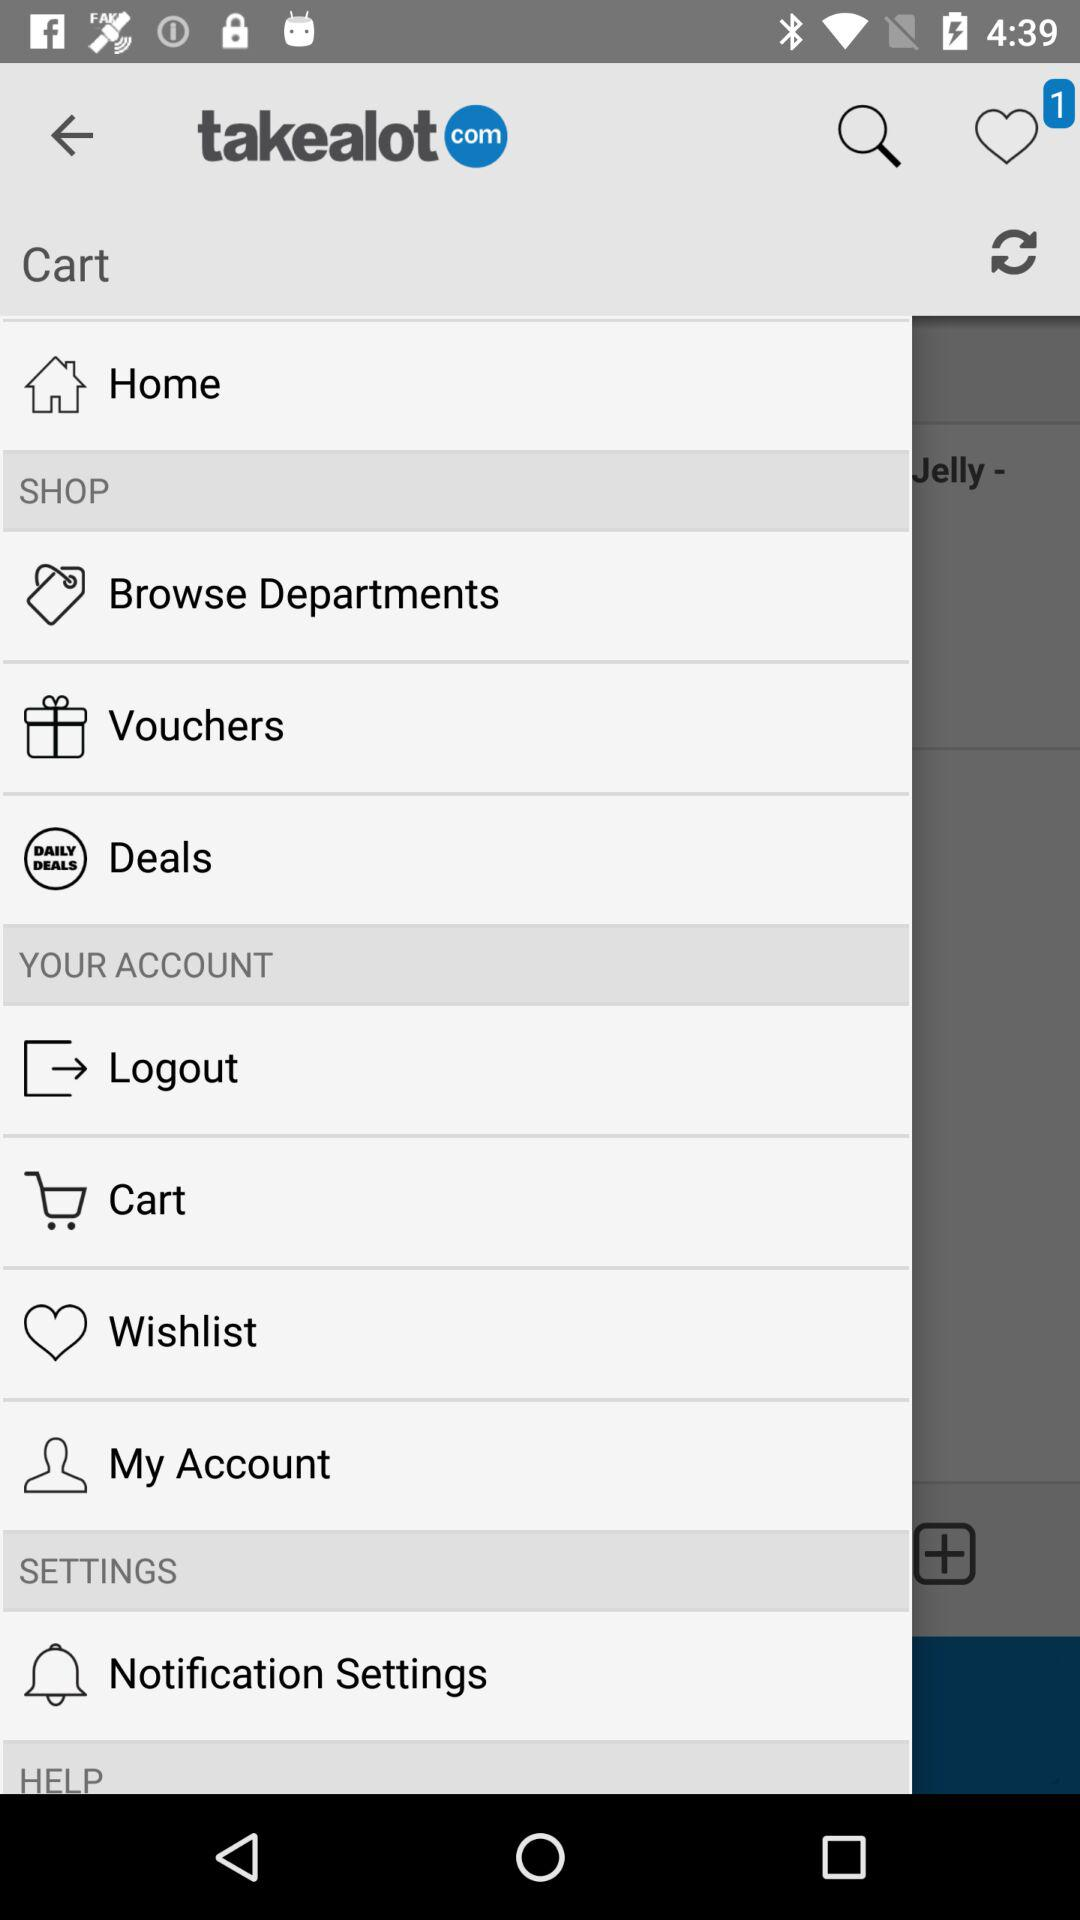How can we get help?
When the provided information is insufficient, respond with <no answer>. <no answer> 